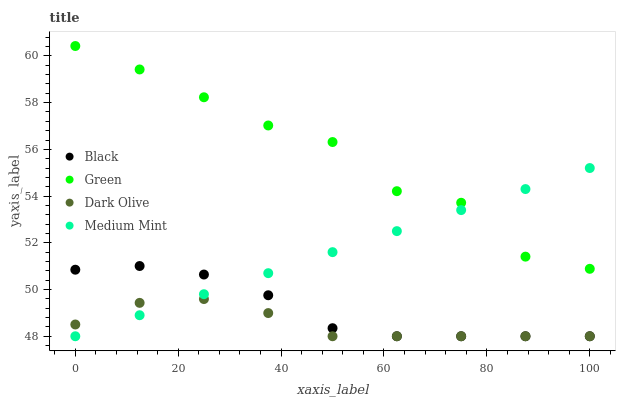Does Dark Olive have the minimum area under the curve?
Answer yes or no. Yes. Does Green have the maximum area under the curve?
Answer yes or no. Yes. Does Green have the minimum area under the curve?
Answer yes or no. No. Does Dark Olive have the maximum area under the curve?
Answer yes or no. No. Is Medium Mint the smoothest?
Answer yes or no. Yes. Is Green the roughest?
Answer yes or no. Yes. Is Dark Olive the smoothest?
Answer yes or no. No. Is Dark Olive the roughest?
Answer yes or no. No. Does Medium Mint have the lowest value?
Answer yes or no. Yes. Does Green have the lowest value?
Answer yes or no. No. Does Green have the highest value?
Answer yes or no. Yes. Does Dark Olive have the highest value?
Answer yes or no. No. Is Black less than Green?
Answer yes or no. Yes. Is Green greater than Black?
Answer yes or no. Yes. Does Medium Mint intersect Green?
Answer yes or no. Yes. Is Medium Mint less than Green?
Answer yes or no. No. Is Medium Mint greater than Green?
Answer yes or no. No. Does Black intersect Green?
Answer yes or no. No. 